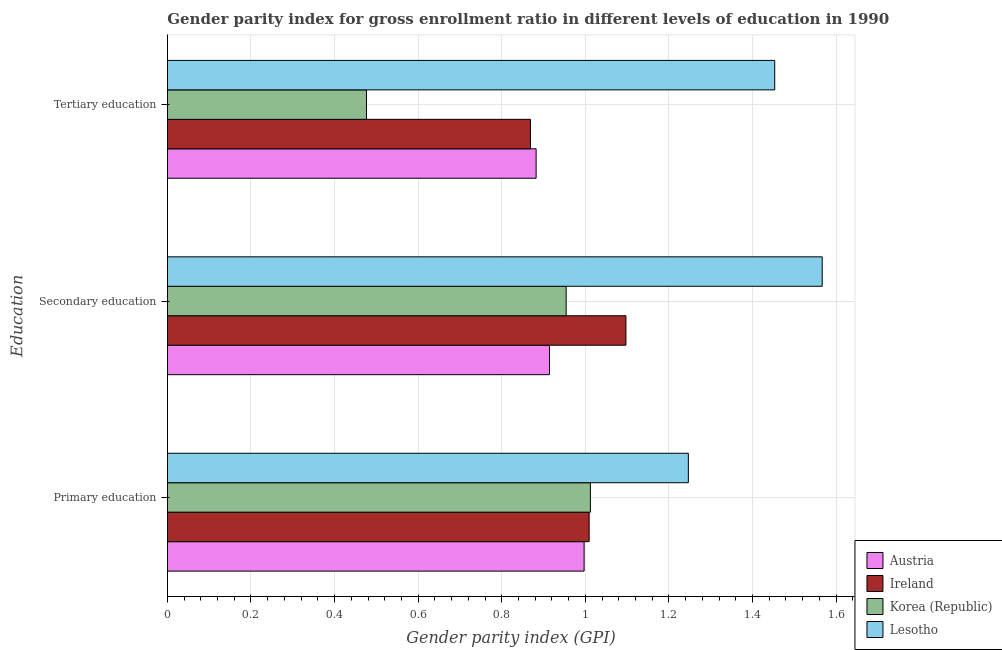How many groups of bars are there?
Provide a succinct answer. 3. Are the number of bars per tick equal to the number of legend labels?
Provide a succinct answer. Yes. What is the label of the 1st group of bars from the top?
Keep it short and to the point. Tertiary education. What is the gender parity index in primary education in Ireland?
Your response must be concise. 1.01. Across all countries, what is the maximum gender parity index in secondary education?
Ensure brevity in your answer.  1.57. Across all countries, what is the minimum gender parity index in primary education?
Provide a short and direct response. 1. In which country was the gender parity index in primary education maximum?
Offer a terse response. Lesotho. In which country was the gender parity index in tertiary education minimum?
Offer a very short reply. Korea (Republic). What is the total gender parity index in secondary education in the graph?
Give a very brief answer. 4.53. What is the difference between the gender parity index in primary education in Korea (Republic) and that in Austria?
Offer a terse response. 0.02. What is the difference between the gender parity index in primary education in Korea (Republic) and the gender parity index in secondary education in Lesotho?
Your answer should be compact. -0.55. What is the average gender parity index in primary education per country?
Your answer should be very brief. 1.07. What is the difference between the gender parity index in primary education and gender parity index in tertiary education in Lesotho?
Ensure brevity in your answer.  -0.21. What is the ratio of the gender parity index in tertiary education in Ireland to that in Austria?
Offer a very short reply. 0.98. Is the gender parity index in primary education in Austria less than that in Ireland?
Make the answer very short. Yes. Is the difference between the gender parity index in secondary education in Ireland and Korea (Republic) greater than the difference between the gender parity index in primary education in Ireland and Korea (Republic)?
Provide a succinct answer. Yes. What is the difference between the highest and the second highest gender parity index in tertiary education?
Your answer should be very brief. 0.57. What is the difference between the highest and the lowest gender parity index in tertiary education?
Your response must be concise. 0.98. Is the sum of the gender parity index in primary education in Ireland and Austria greater than the maximum gender parity index in tertiary education across all countries?
Make the answer very short. Yes. What does the 3rd bar from the top in Primary education represents?
Provide a succinct answer. Ireland. What does the 4th bar from the bottom in Secondary education represents?
Provide a succinct answer. Lesotho. How many bars are there?
Your response must be concise. 12. What is the difference between two consecutive major ticks on the X-axis?
Your answer should be very brief. 0.2. Are the values on the major ticks of X-axis written in scientific E-notation?
Offer a terse response. No. Does the graph contain any zero values?
Keep it short and to the point. No. Does the graph contain grids?
Offer a terse response. Yes. How many legend labels are there?
Ensure brevity in your answer.  4. What is the title of the graph?
Make the answer very short. Gender parity index for gross enrollment ratio in different levels of education in 1990. What is the label or title of the X-axis?
Make the answer very short. Gender parity index (GPI). What is the label or title of the Y-axis?
Offer a very short reply. Education. What is the Gender parity index (GPI) in Austria in Primary education?
Keep it short and to the point. 1. What is the Gender parity index (GPI) in Ireland in Primary education?
Provide a short and direct response. 1.01. What is the Gender parity index (GPI) in Korea (Republic) in Primary education?
Your answer should be very brief. 1.01. What is the Gender parity index (GPI) of Lesotho in Primary education?
Your answer should be compact. 1.25. What is the Gender parity index (GPI) of Austria in Secondary education?
Keep it short and to the point. 0.91. What is the Gender parity index (GPI) of Ireland in Secondary education?
Provide a short and direct response. 1.1. What is the Gender parity index (GPI) of Korea (Republic) in Secondary education?
Give a very brief answer. 0.95. What is the Gender parity index (GPI) of Lesotho in Secondary education?
Offer a very short reply. 1.57. What is the Gender parity index (GPI) of Austria in Tertiary education?
Your answer should be compact. 0.88. What is the Gender parity index (GPI) of Ireland in Tertiary education?
Provide a short and direct response. 0.87. What is the Gender parity index (GPI) in Korea (Republic) in Tertiary education?
Ensure brevity in your answer.  0.48. What is the Gender parity index (GPI) of Lesotho in Tertiary education?
Provide a short and direct response. 1.45. Across all Education, what is the maximum Gender parity index (GPI) in Austria?
Your answer should be compact. 1. Across all Education, what is the maximum Gender parity index (GPI) in Ireland?
Provide a succinct answer. 1.1. Across all Education, what is the maximum Gender parity index (GPI) of Korea (Republic)?
Offer a very short reply. 1.01. Across all Education, what is the maximum Gender parity index (GPI) of Lesotho?
Offer a very short reply. 1.57. Across all Education, what is the minimum Gender parity index (GPI) in Austria?
Ensure brevity in your answer.  0.88. Across all Education, what is the minimum Gender parity index (GPI) of Ireland?
Your answer should be very brief. 0.87. Across all Education, what is the minimum Gender parity index (GPI) in Korea (Republic)?
Provide a succinct answer. 0.48. Across all Education, what is the minimum Gender parity index (GPI) of Lesotho?
Offer a terse response. 1.25. What is the total Gender parity index (GPI) of Austria in the graph?
Your answer should be very brief. 2.79. What is the total Gender parity index (GPI) in Ireland in the graph?
Your response must be concise. 2.98. What is the total Gender parity index (GPI) of Korea (Republic) in the graph?
Keep it short and to the point. 2.44. What is the total Gender parity index (GPI) in Lesotho in the graph?
Your answer should be compact. 4.27. What is the difference between the Gender parity index (GPI) of Austria in Primary education and that in Secondary education?
Provide a succinct answer. 0.08. What is the difference between the Gender parity index (GPI) in Ireland in Primary education and that in Secondary education?
Offer a terse response. -0.09. What is the difference between the Gender parity index (GPI) of Korea (Republic) in Primary education and that in Secondary education?
Make the answer very short. 0.06. What is the difference between the Gender parity index (GPI) in Lesotho in Primary education and that in Secondary education?
Your response must be concise. -0.32. What is the difference between the Gender parity index (GPI) of Austria in Primary education and that in Tertiary education?
Offer a terse response. 0.11. What is the difference between the Gender parity index (GPI) in Ireland in Primary education and that in Tertiary education?
Your answer should be compact. 0.14. What is the difference between the Gender parity index (GPI) of Korea (Republic) in Primary education and that in Tertiary education?
Your answer should be compact. 0.54. What is the difference between the Gender parity index (GPI) in Lesotho in Primary education and that in Tertiary education?
Your answer should be compact. -0.21. What is the difference between the Gender parity index (GPI) of Austria in Secondary education and that in Tertiary education?
Provide a succinct answer. 0.03. What is the difference between the Gender parity index (GPI) of Ireland in Secondary education and that in Tertiary education?
Provide a short and direct response. 0.23. What is the difference between the Gender parity index (GPI) of Korea (Republic) in Secondary education and that in Tertiary education?
Offer a very short reply. 0.48. What is the difference between the Gender parity index (GPI) in Lesotho in Secondary education and that in Tertiary education?
Give a very brief answer. 0.11. What is the difference between the Gender parity index (GPI) of Austria in Primary education and the Gender parity index (GPI) of Ireland in Secondary education?
Provide a short and direct response. -0.1. What is the difference between the Gender parity index (GPI) in Austria in Primary education and the Gender parity index (GPI) in Korea (Republic) in Secondary education?
Offer a very short reply. 0.04. What is the difference between the Gender parity index (GPI) of Austria in Primary education and the Gender parity index (GPI) of Lesotho in Secondary education?
Provide a short and direct response. -0.57. What is the difference between the Gender parity index (GPI) in Ireland in Primary education and the Gender parity index (GPI) in Korea (Republic) in Secondary education?
Offer a terse response. 0.06. What is the difference between the Gender parity index (GPI) of Ireland in Primary education and the Gender parity index (GPI) of Lesotho in Secondary education?
Keep it short and to the point. -0.56. What is the difference between the Gender parity index (GPI) in Korea (Republic) in Primary education and the Gender parity index (GPI) in Lesotho in Secondary education?
Your response must be concise. -0.55. What is the difference between the Gender parity index (GPI) of Austria in Primary education and the Gender parity index (GPI) of Ireland in Tertiary education?
Make the answer very short. 0.13. What is the difference between the Gender parity index (GPI) of Austria in Primary education and the Gender parity index (GPI) of Korea (Republic) in Tertiary education?
Your response must be concise. 0.52. What is the difference between the Gender parity index (GPI) of Austria in Primary education and the Gender parity index (GPI) of Lesotho in Tertiary education?
Your answer should be very brief. -0.46. What is the difference between the Gender parity index (GPI) of Ireland in Primary education and the Gender parity index (GPI) of Korea (Republic) in Tertiary education?
Offer a terse response. 0.53. What is the difference between the Gender parity index (GPI) of Ireland in Primary education and the Gender parity index (GPI) of Lesotho in Tertiary education?
Ensure brevity in your answer.  -0.44. What is the difference between the Gender parity index (GPI) in Korea (Republic) in Primary education and the Gender parity index (GPI) in Lesotho in Tertiary education?
Keep it short and to the point. -0.44. What is the difference between the Gender parity index (GPI) in Austria in Secondary education and the Gender parity index (GPI) in Ireland in Tertiary education?
Your response must be concise. 0.05. What is the difference between the Gender parity index (GPI) in Austria in Secondary education and the Gender parity index (GPI) in Korea (Republic) in Tertiary education?
Provide a short and direct response. 0.44. What is the difference between the Gender parity index (GPI) in Austria in Secondary education and the Gender parity index (GPI) in Lesotho in Tertiary education?
Your answer should be compact. -0.54. What is the difference between the Gender parity index (GPI) in Ireland in Secondary education and the Gender parity index (GPI) in Korea (Republic) in Tertiary education?
Keep it short and to the point. 0.62. What is the difference between the Gender parity index (GPI) in Ireland in Secondary education and the Gender parity index (GPI) in Lesotho in Tertiary education?
Your answer should be very brief. -0.36. What is the difference between the Gender parity index (GPI) in Korea (Republic) in Secondary education and the Gender parity index (GPI) in Lesotho in Tertiary education?
Provide a succinct answer. -0.5. What is the average Gender parity index (GPI) in Austria per Education?
Your response must be concise. 0.93. What is the average Gender parity index (GPI) of Ireland per Education?
Your response must be concise. 0.99. What is the average Gender parity index (GPI) of Korea (Republic) per Education?
Your response must be concise. 0.81. What is the average Gender parity index (GPI) in Lesotho per Education?
Offer a terse response. 1.42. What is the difference between the Gender parity index (GPI) of Austria and Gender parity index (GPI) of Ireland in Primary education?
Offer a very short reply. -0.01. What is the difference between the Gender parity index (GPI) in Austria and Gender parity index (GPI) in Korea (Republic) in Primary education?
Make the answer very short. -0.01. What is the difference between the Gender parity index (GPI) in Austria and Gender parity index (GPI) in Lesotho in Primary education?
Keep it short and to the point. -0.25. What is the difference between the Gender parity index (GPI) of Ireland and Gender parity index (GPI) of Korea (Republic) in Primary education?
Provide a short and direct response. -0. What is the difference between the Gender parity index (GPI) of Ireland and Gender parity index (GPI) of Lesotho in Primary education?
Offer a terse response. -0.24. What is the difference between the Gender parity index (GPI) in Korea (Republic) and Gender parity index (GPI) in Lesotho in Primary education?
Give a very brief answer. -0.23. What is the difference between the Gender parity index (GPI) in Austria and Gender parity index (GPI) in Ireland in Secondary education?
Offer a very short reply. -0.18. What is the difference between the Gender parity index (GPI) of Austria and Gender parity index (GPI) of Korea (Republic) in Secondary education?
Your answer should be very brief. -0.04. What is the difference between the Gender parity index (GPI) of Austria and Gender parity index (GPI) of Lesotho in Secondary education?
Offer a terse response. -0.65. What is the difference between the Gender parity index (GPI) of Ireland and Gender parity index (GPI) of Korea (Republic) in Secondary education?
Offer a terse response. 0.14. What is the difference between the Gender parity index (GPI) in Ireland and Gender parity index (GPI) in Lesotho in Secondary education?
Give a very brief answer. -0.47. What is the difference between the Gender parity index (GPI) in Korea (Republic) and Gender parity index (GPI) in Lesotho in Secondary education?
Make the answer very short. -0.61. What is the difference between the Gender parity index (GPI) in Austria and Gender parity index (GPI) in Ireland in Tertiary education?
Your answer should be compact. 0.01. What is the difference between the Gender parity index (GPI) in Austria and Gender parity index (GPI) in Korea (Republic) in Tertiary education?
Make the answer very short. 0.41. What is the difference between the Gender parity index (GPI) of Austria and Gender parity index (GPI) of Lesotho in Tertiary education?
Offer a terse response. -0.57. What is the difference between the Gender parity index (GPI) of Ireland and Gender parity index (GPI) of Korea (Republic) in Tertiary education?
Give a very brief answer. 0.39. What is the difference between the Gender parity index (GPI) of Ireland and Gender parity index (GPI) of Lesotho in Tertiary education?
Provide a succinct answer. -0.58. What is the difference between the Gender parity index (GPI) of Korea (Republic) and Gender parity index (GPI) of Lesotho in Tertiary education?
Ensure brevity in your answer.  -0.98. What is the ratio of the Gender parity index (GPI) in Austria in Primary education to that in Secondary education?
Ensure brevity in your answer.  1.09. What is the ratio of the Gender parity index (GPI) in Ireland in Primary education to that in Secondary education?
Your response must be concise. 0.92. What is the ratio of the Gender parity index (GPI) of Korea (Republic) in Primary education to that in Secondary education?
Give a very brief answer. 1.06. What is the ratio of the Gender parity index (GPI) of Lesotho in Primary education to that in Secondary education?
Offer a terse response. 0.8. What is the ratio of the Gender parity index (GPI) of Austria in Primary education to that in Tertiary education?
Offer a terse response. 1.13. What is the ratio of the Gender parity index (GPI) of Ireland in Primary education to that in Tertiary education?
Provide a succinct answer. 1.16. What is the ratio of the Gender parity index (GPI) in Korea (Republic) in Primary education to that in Tertiary education?
Provide a succinct answer. 2.12. What is the ratio of the Gender parity index (GPI) in Lesotho in Primary education to that in Tertiary education?
Provide a succinct answer. 0.86. What is the ratio of the Gender parity index (GPI) in Austria in Secondary education to that in Tertiary education?
Offer a very short reply. 1.04. What is the ratio of the Gender parity index (GPI) of Ireland in Secondary education to that in Tertiary education?
Your answer should be compact. 1.26. What is the ratio of the Gender parity index (GPI) in Korea (Republic) in Secondary education to that in Tertiary education?
Provide a succinct answer. 2. What is the ratio of the Gender parity index (GPI) of Lesotho in Secondary education to that in Tertiary education?
Offer a terse response. 1.08. What is the difference between the highest and the second highest Gender parity index (GPI) in Austria?
Ensure brevity in your answer.  0.08. What is the difference between the highest and the second highest Gender parity index (GPI) of Ireland?
Provide a succinct answer. 0.09. What is the difference between the highest and the second highest Gender parity index (GPI) of Korea (Republic)?
Your answer should be very brief. 0.06. What is the difference between the highest and the second highest Gender parity index (GPI) of Lesotho?
Your answer should be compact. 0.11. What is the difference between the highest and the lowest Gender parity index (GPI) in Austria?
Keep it short and to the point. 0.11. What is the difference between the highest and the lowest Gender parity index (GPI) in Ireland?
Your answer should be very brief. 0.23. What is the difference between the highest and the lowest Gender parity index (GPI) in Korea (Republic)?
Keep it short and to the point. 0.54. What is the difference between the highest and the lowest Gender parity index (GPI) in Lesotho?
Ensure brevity in your answer.  0.32. 